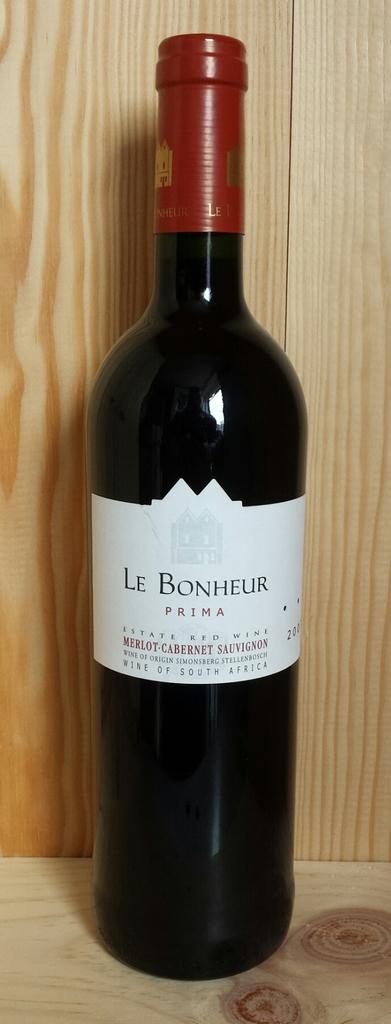Who makes that wine?
Keep it short and to the point. Le bonheur. 